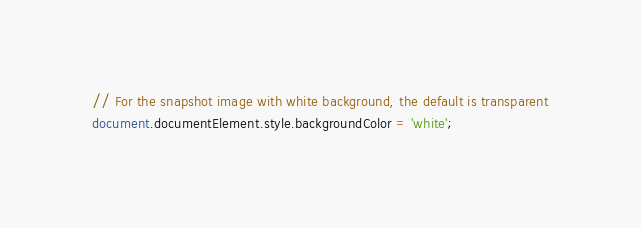<code> <loc_0><loc_0><loc_500><loc_500><_TypeScript_>// For the snapshot image with white background, the default is transparent
document.documentElement.style.backgroundColor = 'white';
</code> 